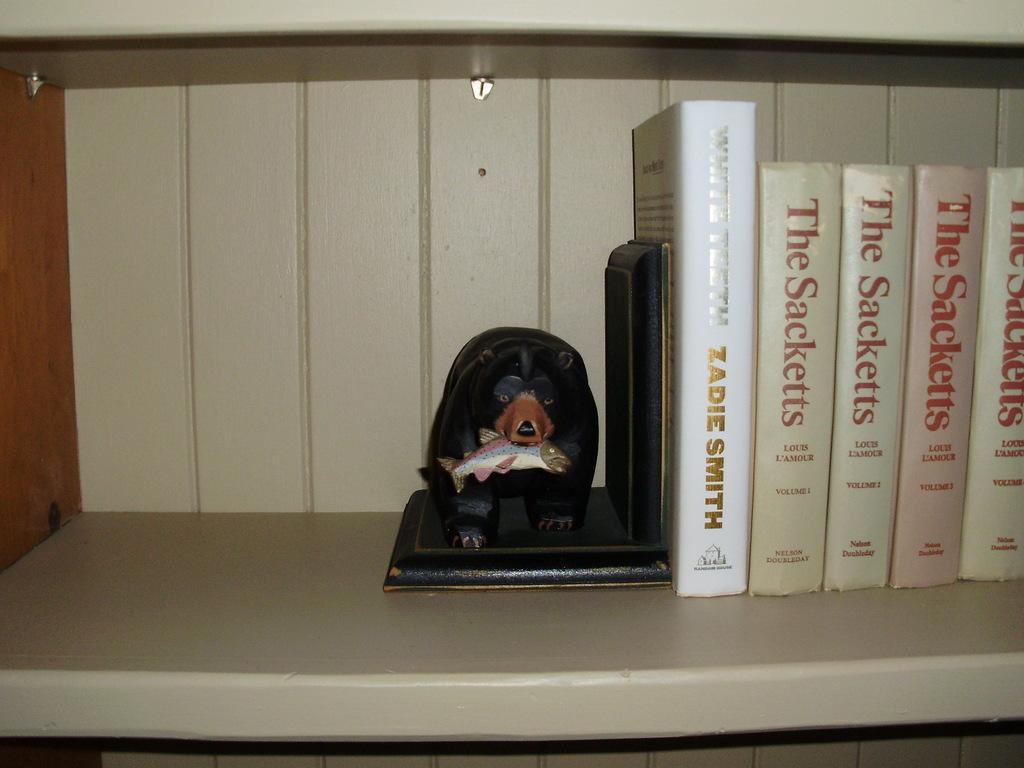How would you summarize this image in a sentence or two? In this picture there are books in the shelf and there is a sculpture of a bear holding the fish. 